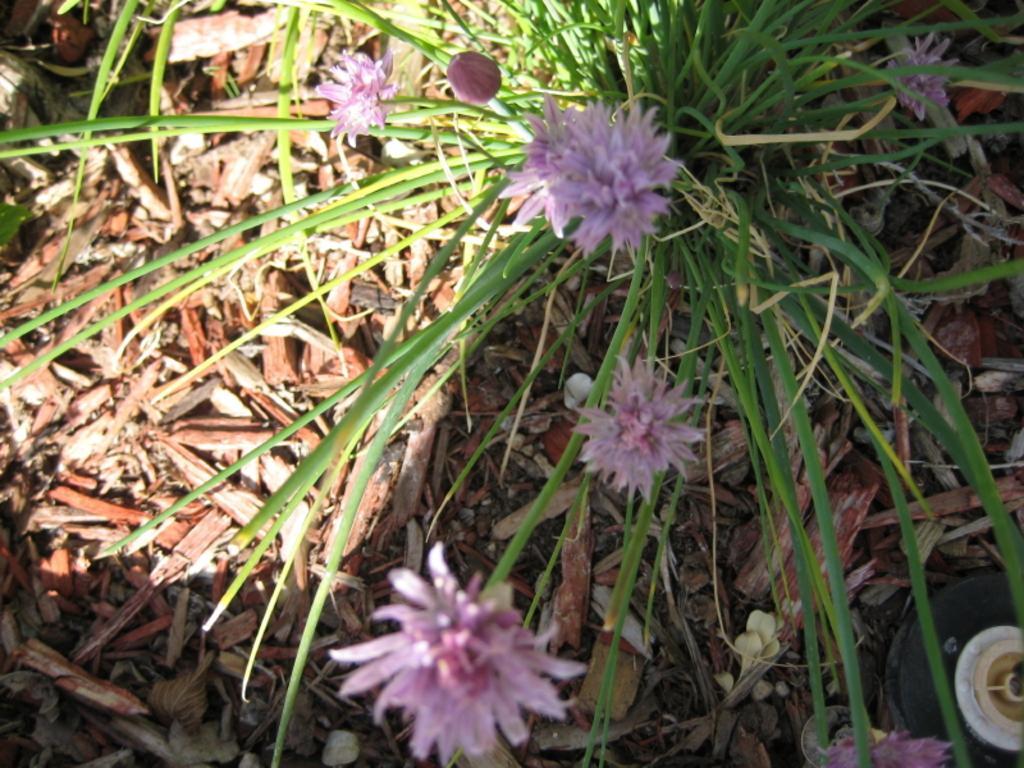In one or two sentences, can you explain what this image depicts? In this image I can see few flowers which are pink in color and a plant which is green in color. I can see few brown colored objects on the ground. 